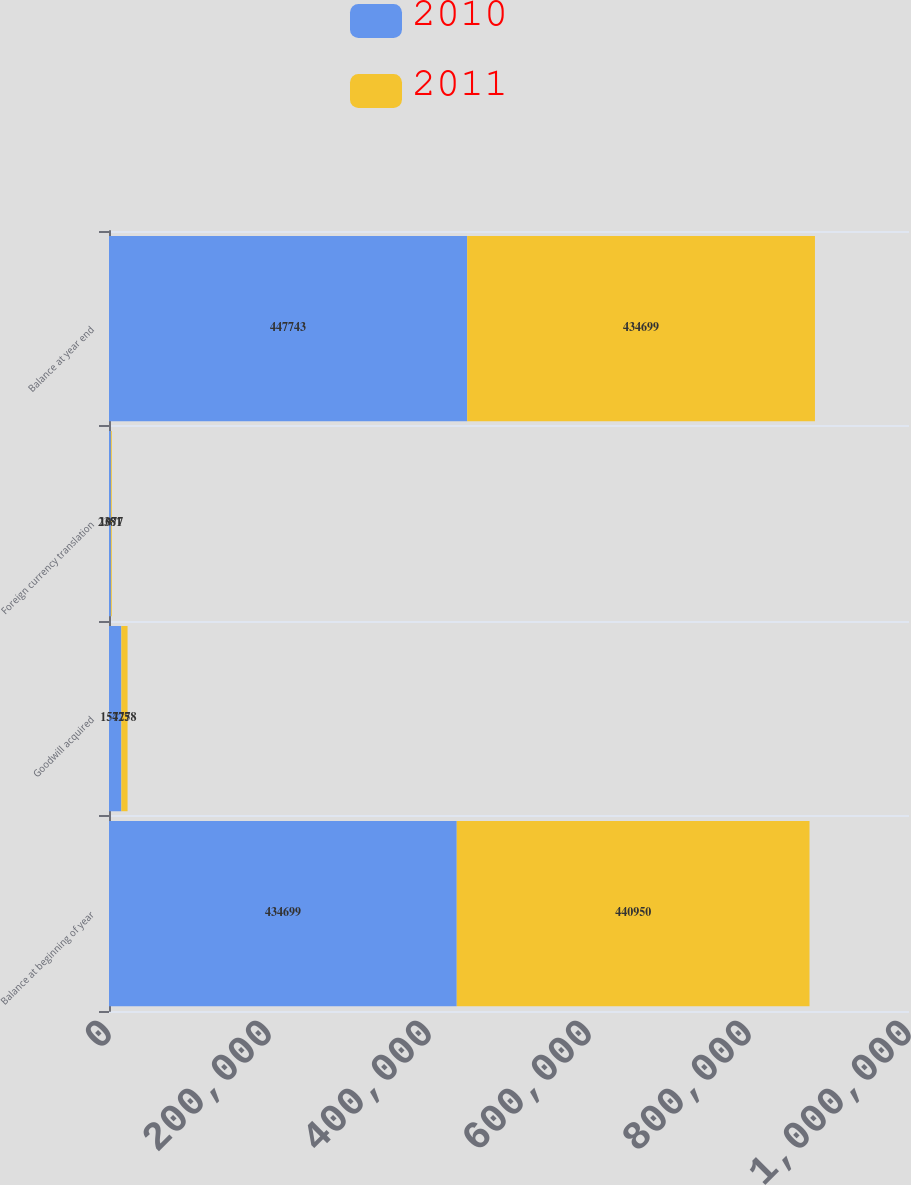Convert chart to OTSL. <chart><loc_0><loc_0><loc_500><loc_500><stacked_bar_chart><ecel><fcel>Balance at beginning of year<fcel>Goodwill acquired<fcel>Foreign currency translation<fcel>Balance at year end<nl><fcel>2010<fcel>434699<fcel>15425<fcel>2381<fcel>447743<nl><fcel>2011<fcel>440950<fcel>7778<fcel>1077<fcel>434699<nl></chart> 